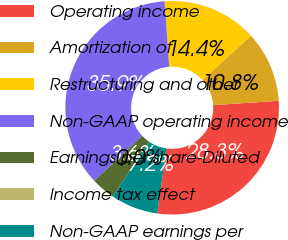Convert chart. <chart><loc_0><loc_0><loc_500><loc_500><pie_chart><fcel>Operating income<fcel>Amortization of<fcel>Restructuring and other<fcel>Non-GAAP operating income<fcel>Earnings per share-Diluted<fcel>Income tax effect<fcel>Non-GAAP earnings per<nl><fcel>28.27%<fcel>10.76%<fcel>14.35%<fcel>35.86%<fcel>3.59%<fcel>0.0%<fcel>7.17%<nl></chart> 